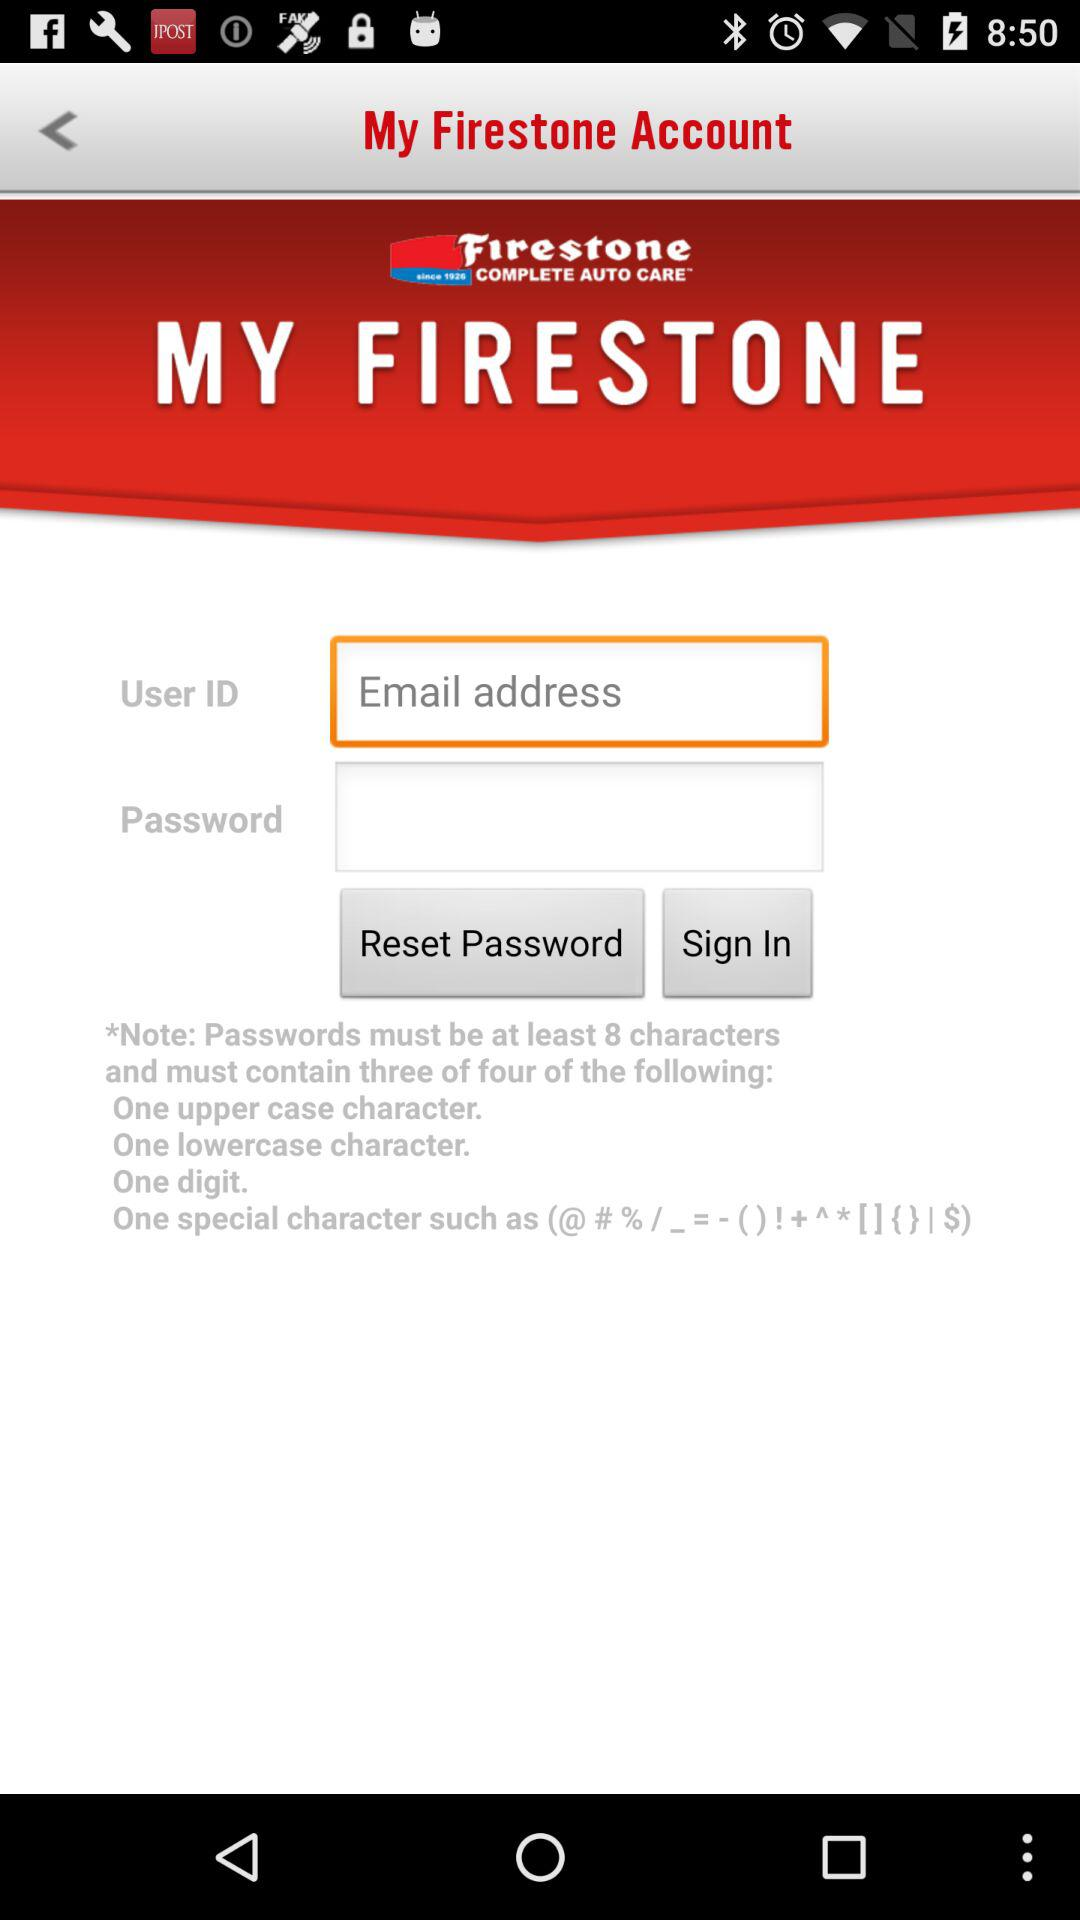What is the email address?
When the provided information is insufficient, respond with <no answer>. <no answer> 